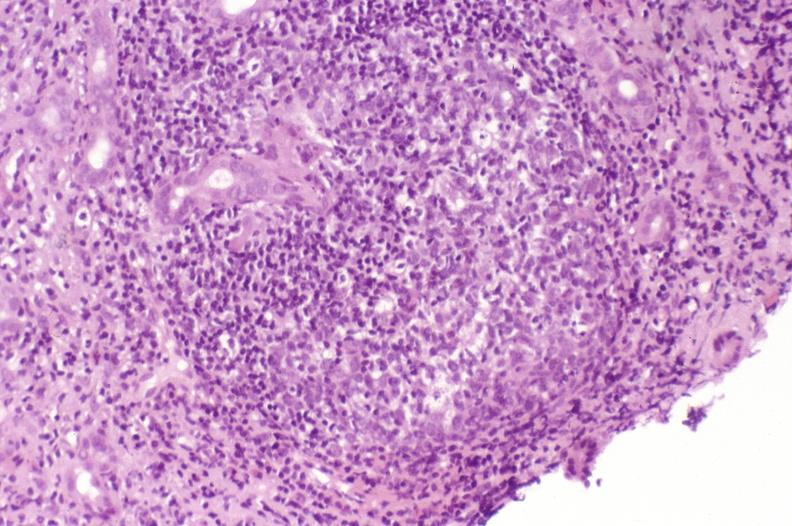what does this image show?
Answer the question using a single word or phrase. Recurrent hepatitis c virus 